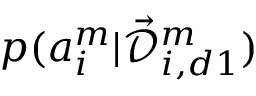<formula> <loc_0><loc_0><loc_500><loc_500>p ( a _ { i } ^ { m } | \mathcal { \vec { D } } _ { i , d 1 } ^ { m } )</formula> 